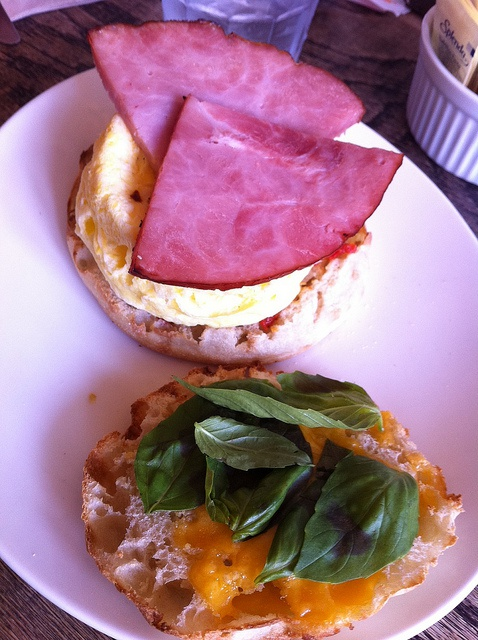Describe the objects in this image and their specific colors. I can see bowl in lavender, violet, and brown tones, sandwich in violet, white, and brown tones, sandwich in violet, black, brown, maroon, and darkgreen tones, dining table in violet, black, purple, and navy tones, and bowl in violet and purple tones in this image. 